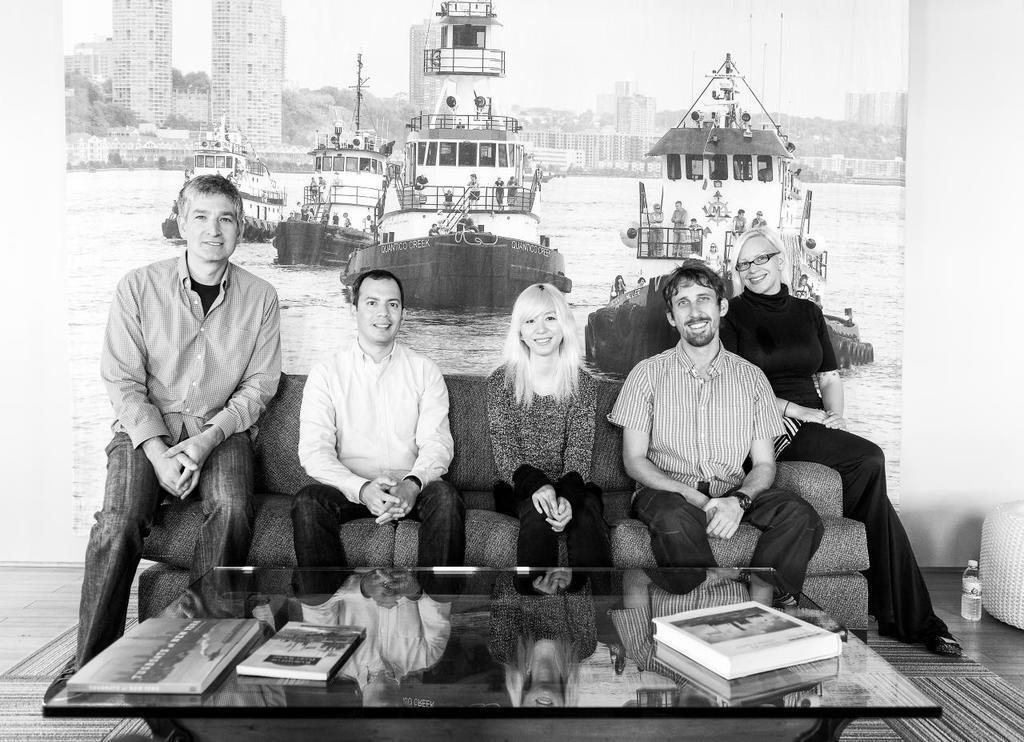Please provide a concise description of this image. This black and white picture is taken inside a room. There are five people sitting on the couch and they all are smiling. In front of them there is glass table and books are placed on it. At the left corner of the image there is bottle on the floor. Behind them there is a wall and on the wall there is big wall poster on it. In the poster there is water, ships, buildings, trees and sky.  